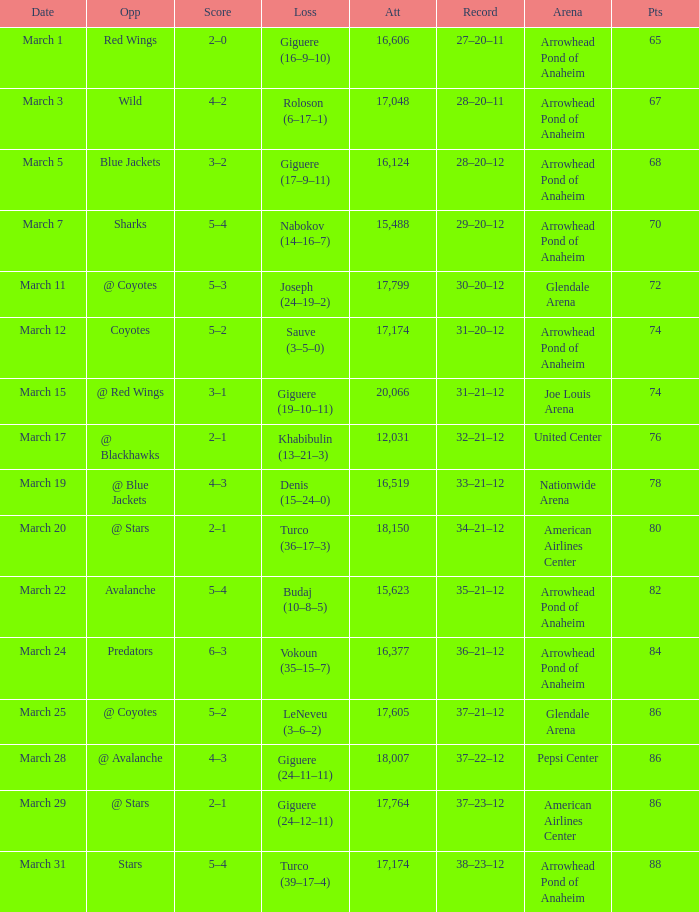What is the Attendance at Joe Louis Arena? 20066.0. 